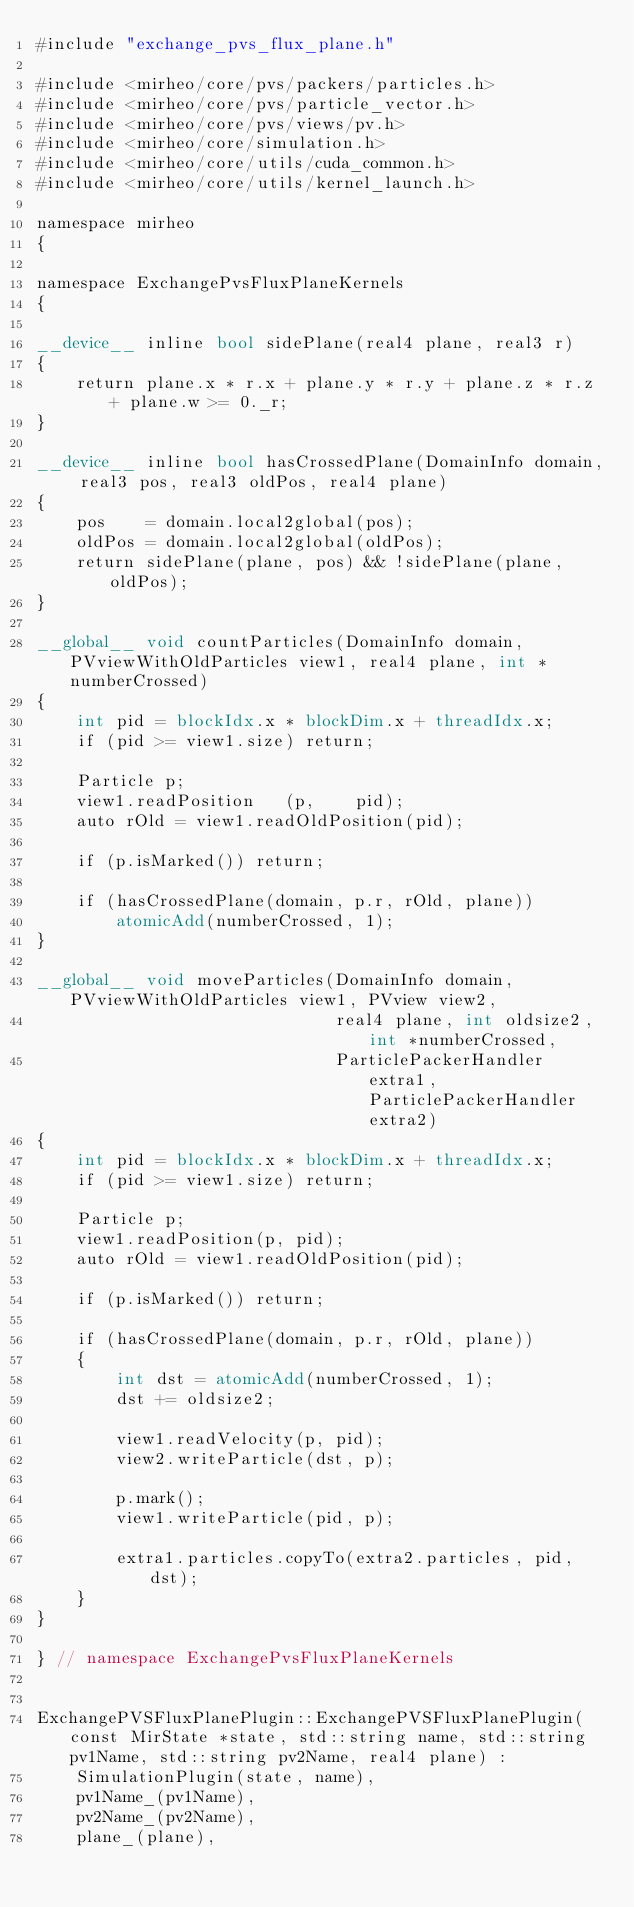<code> <loc_0><loc_0><loc_500><loc_500><_Cuda_>#include "exchange_pvs_flux_plane.h"

#include <mirheo/core/pvs/packers/particles.h>
#include <mirheo/core/pvs/particle_vector.h>
#include <mirheo/core/pvs/views/pv.h>
#include <mirheo/core/simulation.h>
#include <mirheo/core/utils/cuda_common.h>
#include <mirheo/core/utils/kernel_launch.h>

namespace mirheo
{

namespace ExchangePvsFluxPlaneKernels
{

__device__ inline bool sidePlane(real4 plane, real3 r)
{
    return plane.x * r.x + plane.y * r.y + plane.z * r.z + plane.w >= 0._r;
}

__device__ inline bool hasCrossedPlane(DomainInfo domain, real3 pos, real3 oldPos, real4 plane)
{
    pos    = domain.local2global(pos);
    oldPos = domain.local2global(oldPos);
    return sidePlane(plane, pos) && !sidePlane(plane, oldPos);
}

__global__ void countParticles(DomainInfo domain, PVviewWithOldParticles view1, real4 plane, int *numberCrossed)
{
    int pid = blockIdx.x * blockDim.x + threadIdx.x;
    if (pid >= view1.size) return;

    Particle p;
    view1.readPosition   (p,    pid);
    auto rOld = view1.readOldPosition(pid);

    if (p.isMarked()) return;

    if (hasCrossedPlane(domain, p.r, rOld, plane))
        atomicAdd(numberCrossed, 1);
}

__global__ void moveParticles(DomainInfo domain, PVviewWithOldParticles view1, PVview view2,
                              real4 plane, int oldsize2, int *numberCrossed,
                              ParticlePackerHandler extra1, ParticlePackerHandler extra2)
{
    int pid = blockIdx.x * blockDim.x + threadIdx.x;
    if (pid >= view1.size) return;

    Particle p;
    view1.readPosition(p, pid);
    auto rOld = view1.readOldPosition(pid);

    if (p.isMarked()) return;
    
    if (hasCrossedPlane(domain, p.r, rOld, plane))
    {        
        int dst = atomicAdd(numberCrossed, 1);
        dst += oldsize2;

        view1.readVelocity(p, pid);
        view2.writeParticle(dst, p);

        p.mark();
        view1.writeParticle(pid, p);

        extra1.particles.copyTo(extra2.particles, pid, dst);
    }
}

} // namespace ExchangePvsFluxPlaneKernels


ExchangePVSFluxPlanePlugin::ExchangePVSFluxPlanePlugin(const MirState *state, std::string name, std::string pv1Name, std::string pv2Name, real4 plane) :
    SimulationPlugin(state, name),
    pv1Name_(pv1Name),
    pv2Name_(pv2Name),
    plane_(plane),</code> 